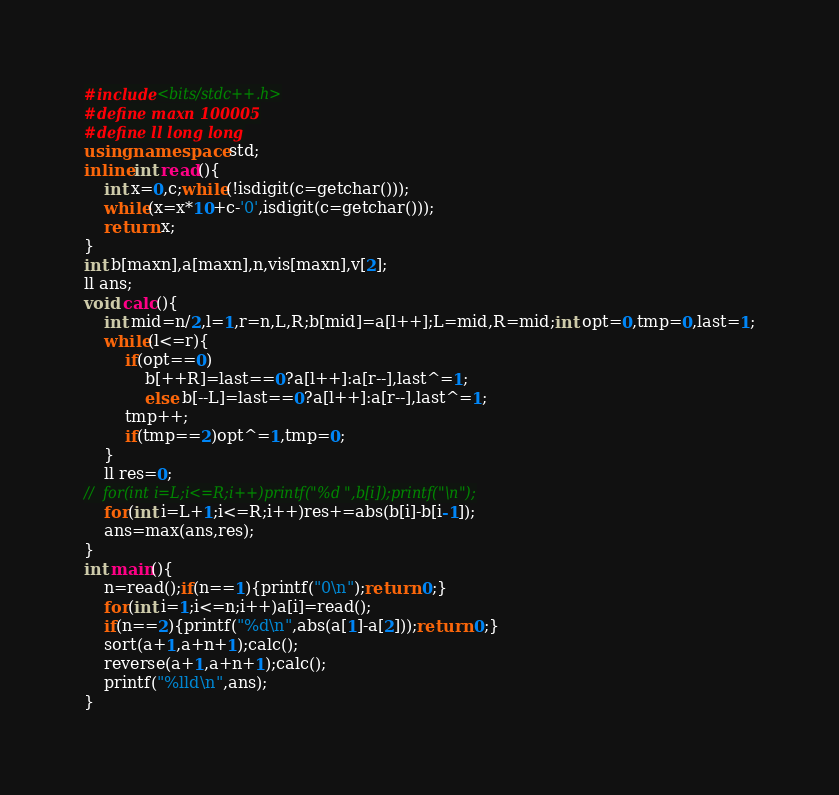<code> <loc_0><loc_0><loc_500><loc_500><_C++_>#include<bits/stdc++.h>
#define maxn 100005
#define ll long long
using namespace std;
inline int read(){
	int x=0,c;while(!isdigit(c=getchar()));
	while(x=x*10+c-'0',isdigit(c=getchar()));
	return x;
}
int b[maxn],a[maxn],n,vis[maxn],v[2];
ll ans;
void calc(){
	int mid=n/2,l=1,r=n,L,R;b[mid]=a[l++];L=mid,R=mid;int opt=0,tmp=0,last=1;
	while(l<=r){
		if(opt==0)
			b[++R]=last==0?a[l++]:a[r--],last^=1;
			else b[--L]=last==0?a[l++]:a[r--],last^=1;
		tmp++;
		if(tmp==2)opt^=1,tmp=0;
	}
	ll res=0;
//	for(int i=L;i<=R;i++)printf("%d ",b[i]);printf("\n");
	for(int i=L+1;i<=R;i++)res+=abs(b[i]-b[i-1]);
	ans=max(ans,res);
}
int main(){
	n=read();if(n==1){printf("0\n");return 0;}
	for(int i=1;i<=n;i++)a[i]=read();
	if(n==2){printf("%d\n",abs(a[1]-a[2]));return 0;}
	sort(a+1,a+n+1);calc();
	reverse(a+1,a+n+1);calc();
	printf("%lld\n",ans);
}</code> 